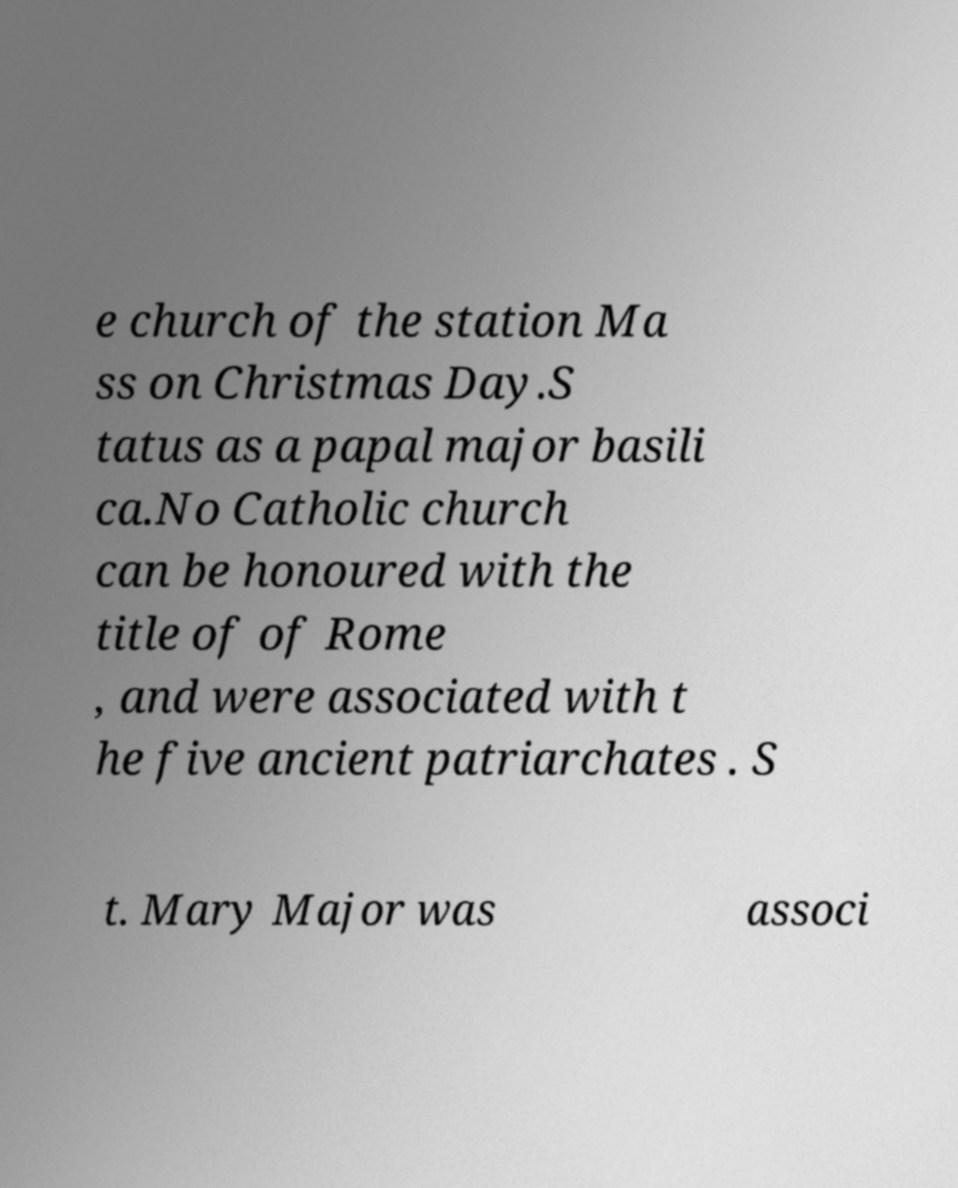Please read and relay the text visible in this image. What does it say? e church of the station Ma ss on Christmas Day.S tatus as a papal major basili ca.No Catholic church can be honoured with the title of of Rome , and were associated with t he five ancient patriarchates . S t. Mary Major was associ 